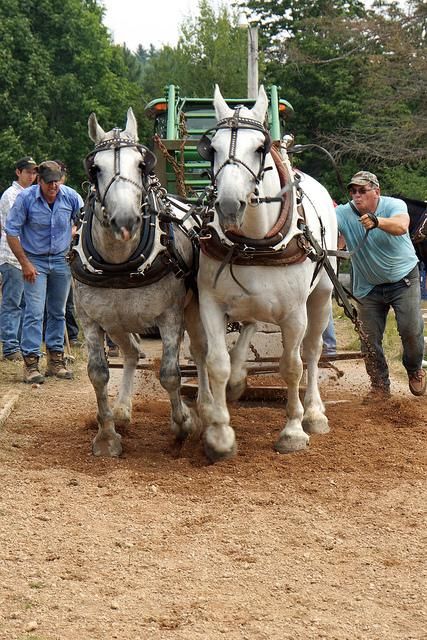What is the man on the right doing? Please explain your reasoning. controlling horses. These are powerful working animals that need to be guided by a human. 